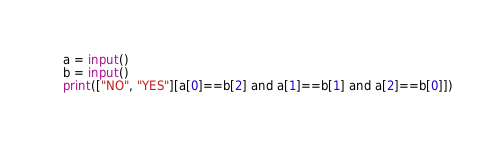<code> <loc_0><loc_0><loc_500><loc_500><_Python_>a = input()
b = input()
print(["NO", "YES"][a[0]==b[2] and a[1]==b[1] and a[2]==b[0]])</code> 